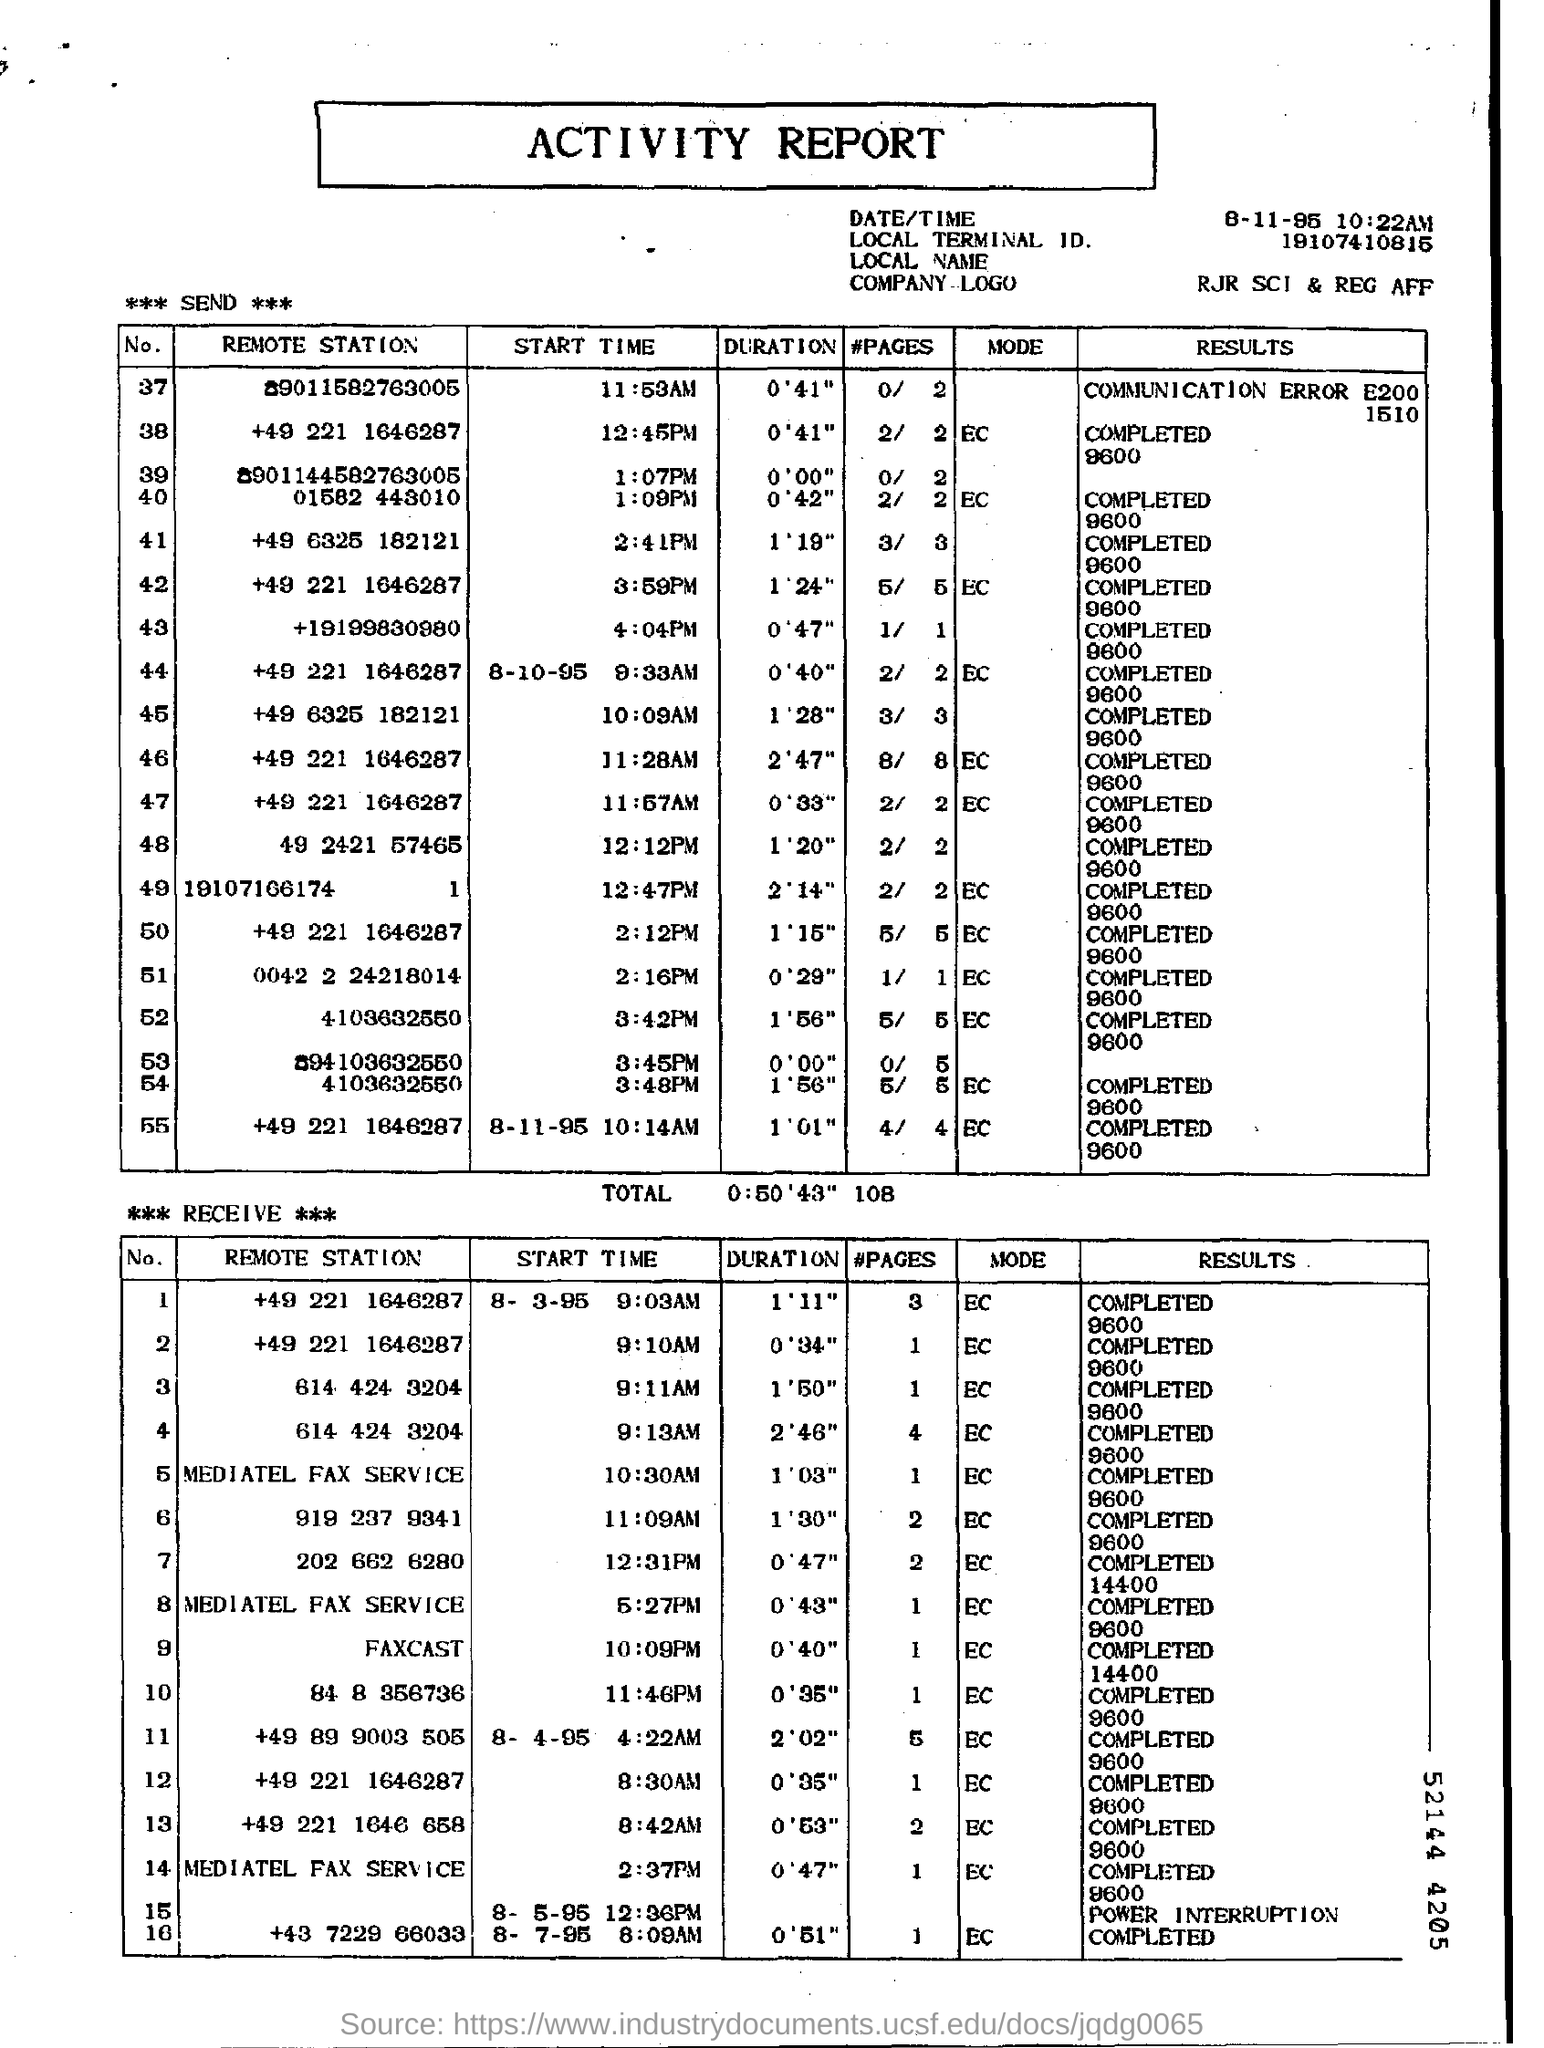Identify some key points in this picture. The start time is item number 37. It is currently 11:53 AM. 